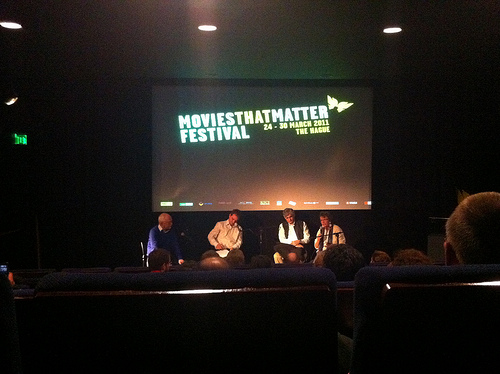<image>
Is the man in the seat? No. The man is not contained within the seat. These objects have a different spatial relationship. 